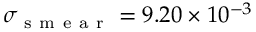<formula> <loc_0><loc_0><loc_500><loc_500>\sigma _ { s m e a r } = 9 . 2 0 \times 1 0 ^ { - 3 }</formula> 